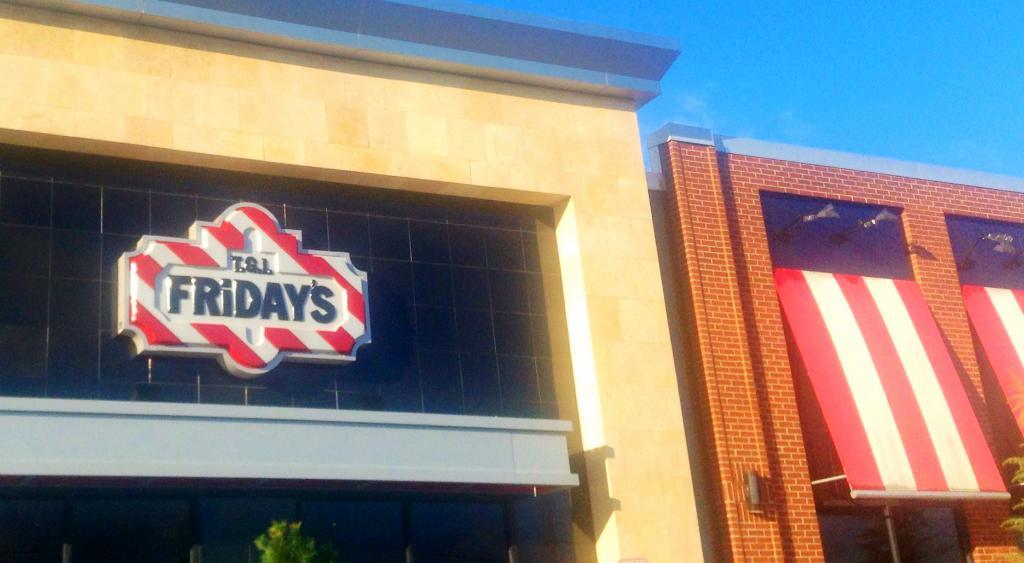What structures are located in the center of the image? There are two buildings in the center of the image. What else can be seen in the center of the image besides the buildings? There are some boards visible in the center of the image. What type of vegetation is at the bottom of the image? There are trees at the bottom of the image. What is visible at the top of the image? The sky is visible at the top of the image. Can you tell me how many notebooks are lying on the ground in the image? There are no notebooks present in the image. What type of wall can be seen supporting the trees in the image? There is no wall present in the image; only trees are visible at the bottom. 